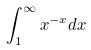Convert formula to latex. <formula><loc_0><loc_0><loc_500><loc_500>\int _ { 1 } ^ { \infty } x ^ { - x } d x</formula> 